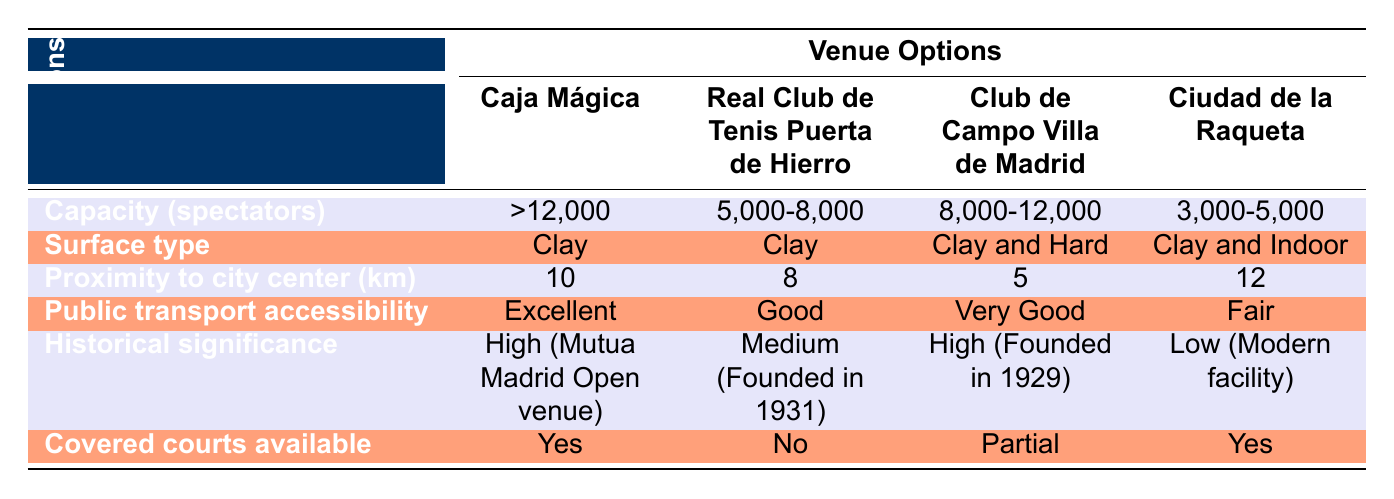What is the capacity of Caja Mágica? The capacity of Caja Mágica is listed in the table as ">12,000".
Answer: >12,000 Which venue has the best public transport accessibility? According to the table, Caja Mágica has "Excellent" public transport accessibility, which is higher than the others.
Answer: Caja Mágica How many more spectators can Club de Campo Villa de Madrid accommodate compared to Ciudad de la Raqueta? Club de Campo Villa de Madrid can accommodate "8,000-12,000" and Ciudad de la Raqueta can accommodate "3,000-5,000". Calculating the difference: the maximum capacity for Club de Campo is 12,000 and the minimum for Ciudad de la Raqueta is 3,000, so 12,000 - 3,000 = 9,000. The minimum for Club de Campo is 8,000 and the maximum for Ciudad de la Raqueta is 5,000, so 8,000 - 5,000 = 3,000. Thus, Club de Campo can accommodate between 3,000 and 9,000 more spectators, depending on their respective capacities.
Answer: Between 3,000 and 9,000 Does Ciudad de la Raqueta have covered courts available? According to the data, Ciudad de la Raqueta has "Yes" for covered courts available, which means it does provide covered facilities.
Answer: Yes Which venue has both high historical significance and excellent public transport accessibility? Reviewing the table, Caja Mágica has "High" historical significance and "Excellent" public transport accessibility, making it the only venue with both characteristics.
Answer: Caja Mágica What is the average proximity to the city center of the venues? To find the average, we add the proximities: 10 + 8 + 5 + 12 = 35. Then we divide by the number of venues (4), giving us an average of 35 / 4 = 8.75 km.
Answer: 8.75 km Which surfaces are available at Club de Campo Villa de Madrid? The table indicates that Club de Campo Villa de Madrid has "Clay and Hard" surfaces available for play.
Answer: Clay and Hard Is there a venue with both a capacity of less than 5,000 spectators and no covered courts? The table shows Ciudad de la Raqueta with a capacity of "3,000-5,000" spectators and "Yes" for covered courts available. Real Club de Tenis Puerta de Hierro has a capacity of "5,000-8,000" and "No" for covered courts. However, since it does not meet the spectator capacity requirement, the answer is negative for a venue fitting both criteria. Thus, the answer is no.
Answer: No 